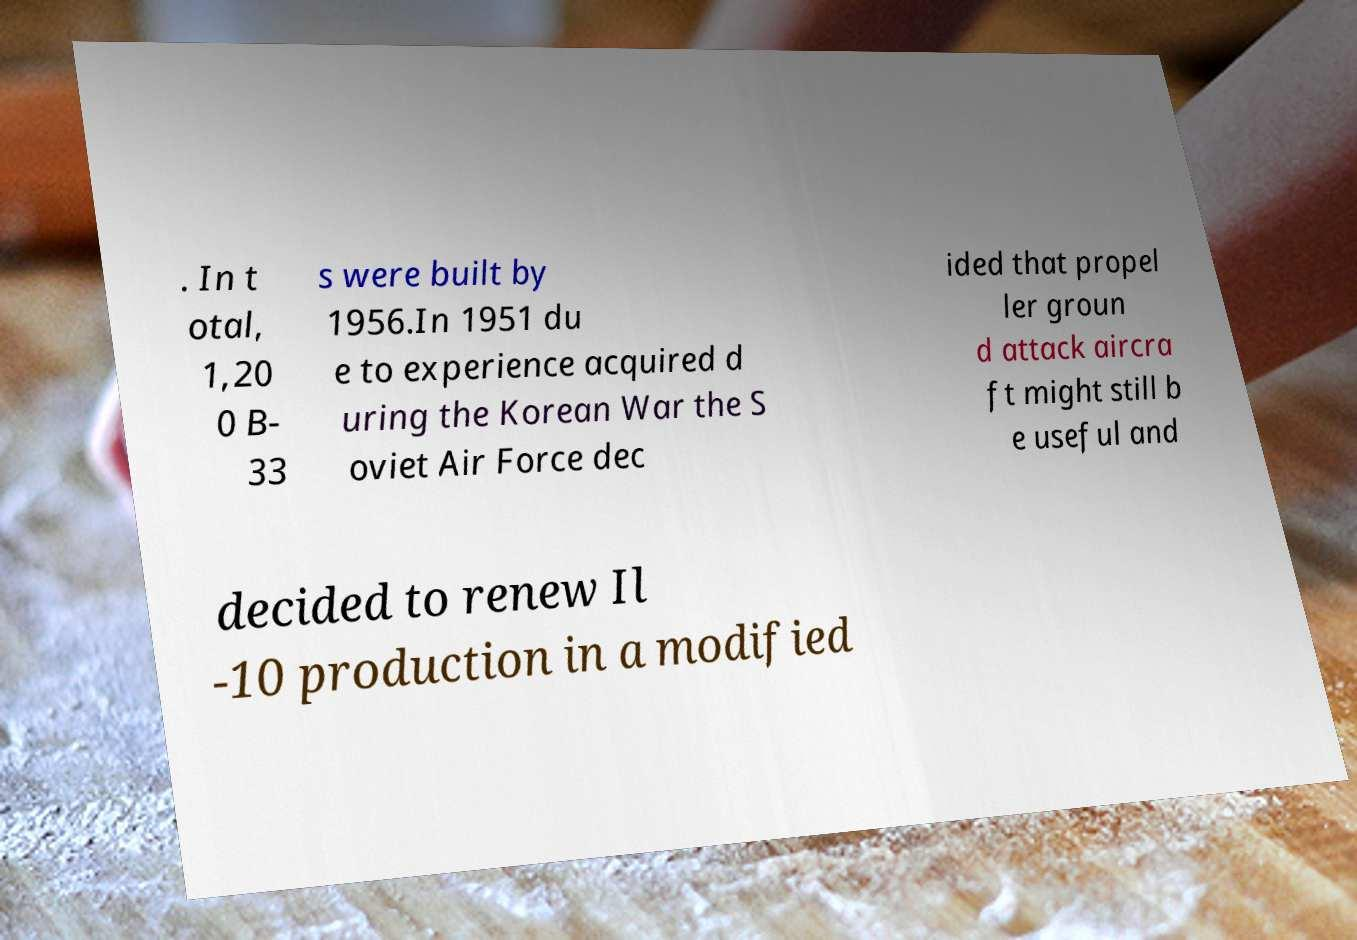I need the written content from this picture converted into text. Can you do that? . In t otal, 1,20 0 B- 33 s were built by 1956.In 1951 du e to experience acquired d uring the Korean War the S oviet Air Force dec ided that propel ler groun d attack aircra ft might still b e useful and decided to renew Il -10 production in a modified 